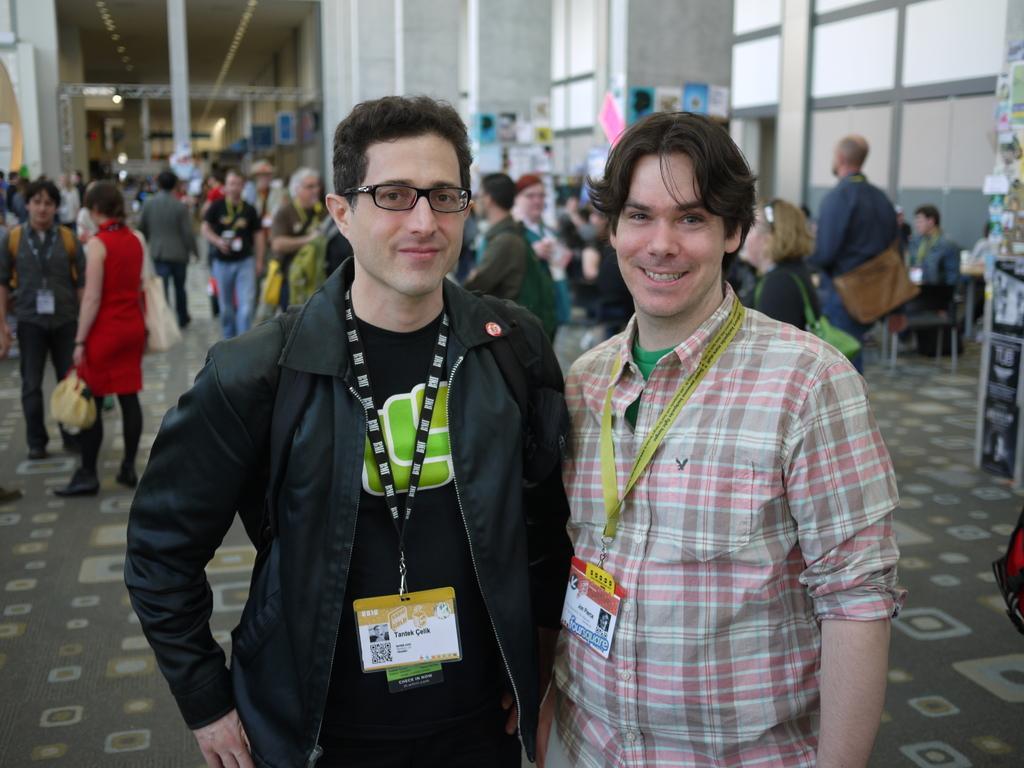Can you describe this image briefly? In this image we can see few people standing on the floor, few posts attached to the pillar and a board on the right side. 